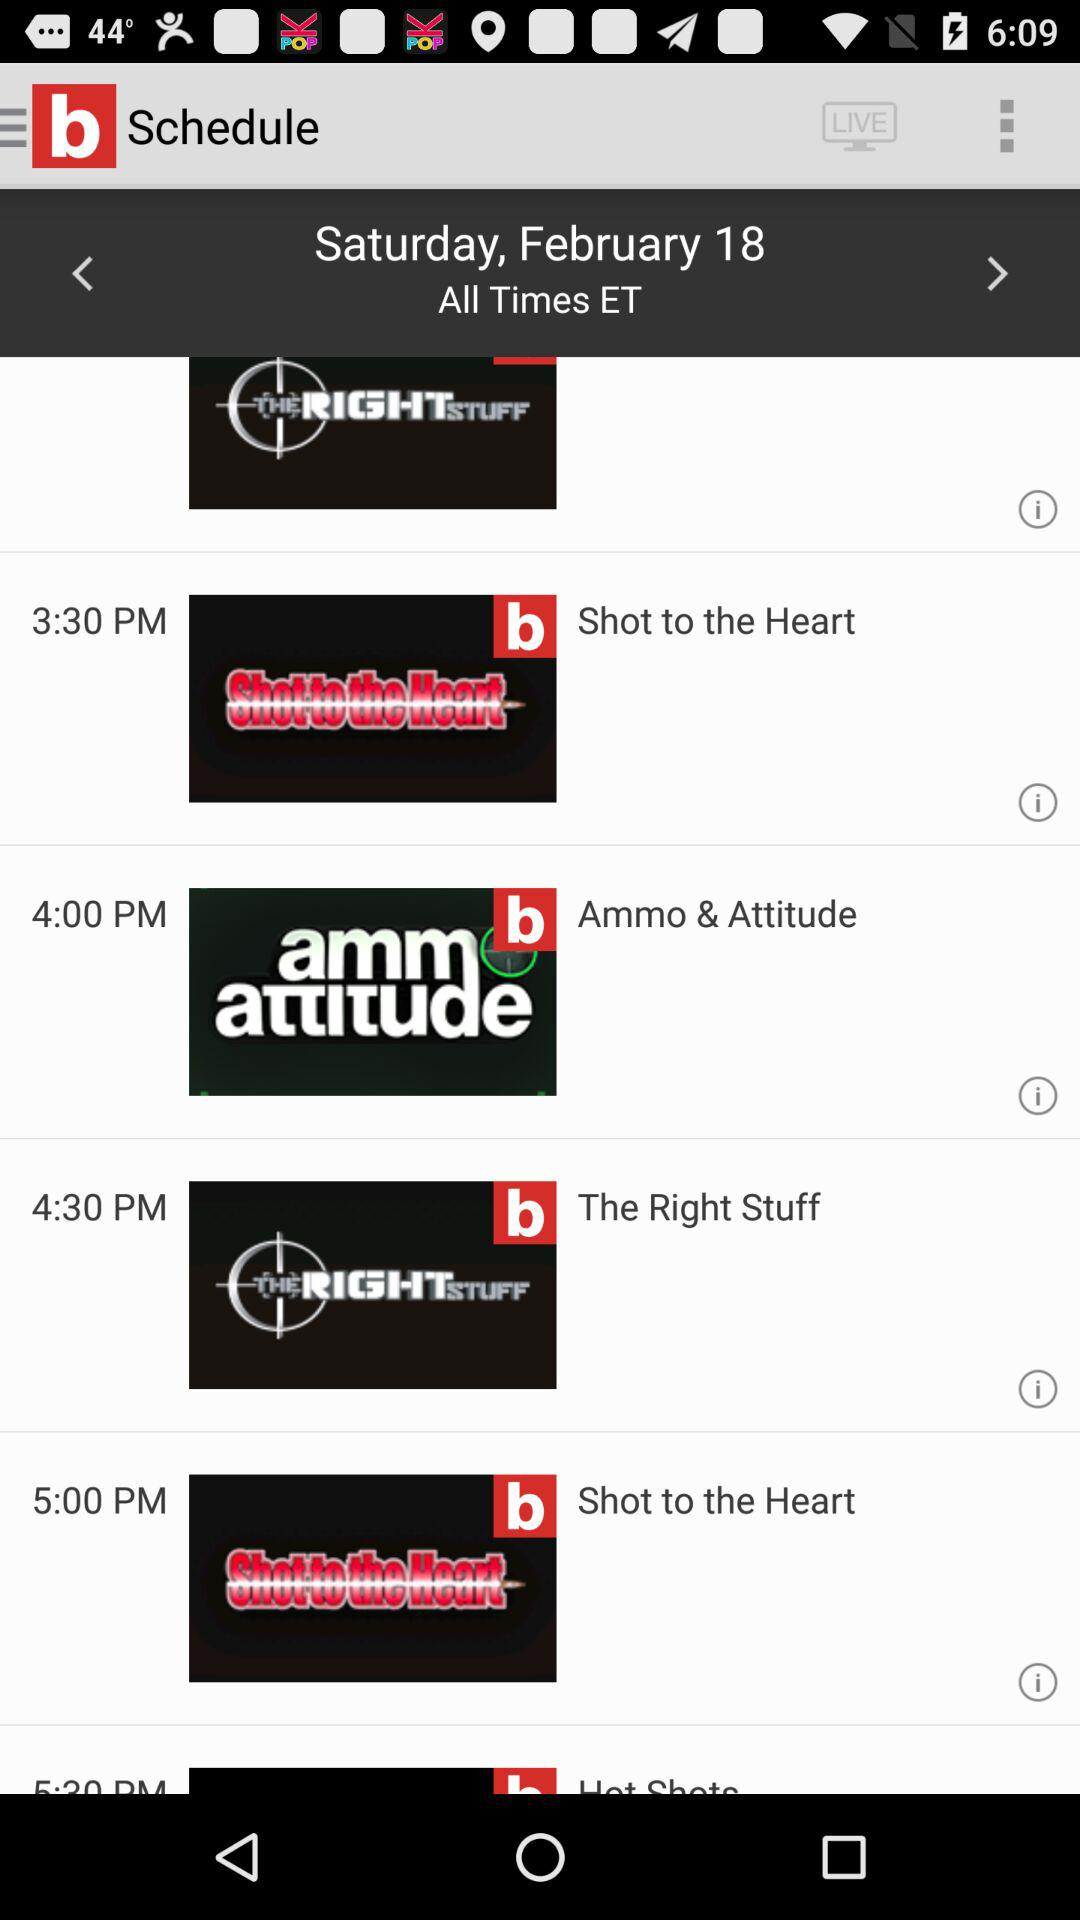What day is it on February 18? The day is Saturday. 